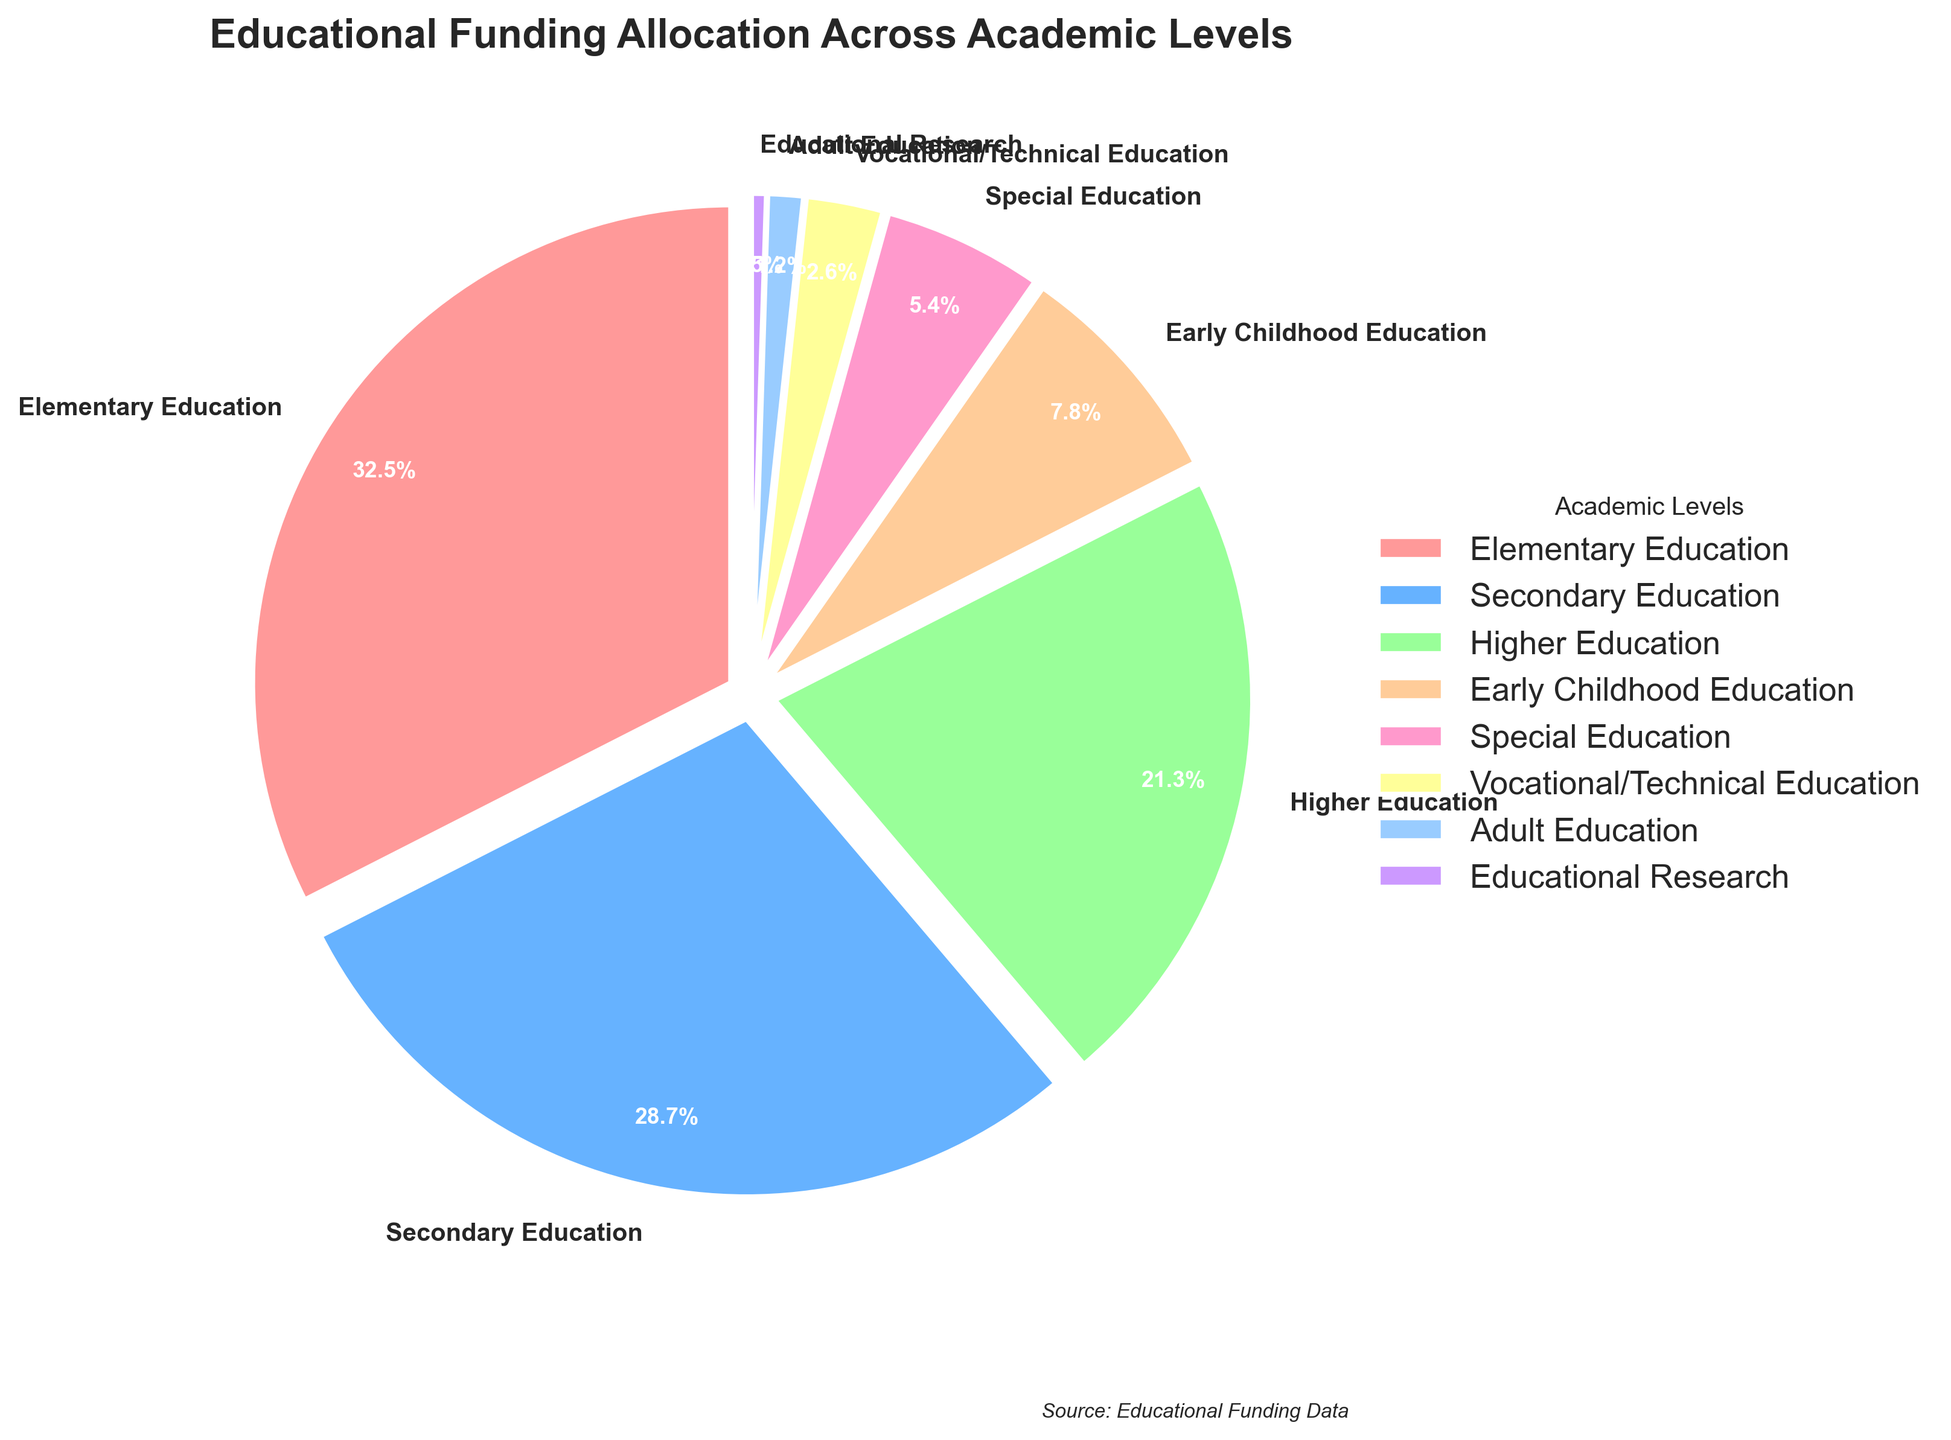Which academic level receives the largest percentage of funding? The pie chart shows the breakdown of funding allocation, and the slice representing Elementary Education is the largest. Therefore, Elementary Education has the largest percentage.
Answer: Elementary Education What is the total percentage of funding allocated to Secondary and Higher Education combined? From the chart, Secondary Education has 28.7% and Higher Education has 21.3%. Adding these two values gives 28.7 + 21.3 = 50.0%.
Answer: 50.0% How does the funding for Early Childhood Education compare to that for Special Education? The chart shows Early Childhood Education at 7.8% and Special Education at 5.4%. Early Childhood Education receives a higher percentage of funding compared to Special Education.
Answer: Early Childhood Education receives more funding Which allocation is smaller: Vocational/Technical Education or Adult Education? The pie chart shows Vocational/Technical Education at 2.6% and Adult Education at 1.2%. Comparing these, Adult Education has a smaller allocation.
Answer: Adult Education Estimate the combined funding percentage for the three smallest categories. The smallest categories in terms of funding are Educational Research (0.5%), Adult Education (1.2%), and Vocational/Technical Education (2.6%). Summing these gives 0.5 + 1.2 + 2.6 = 4.3%.
Answer: 4.3% What is the color of the segment representing Higher Education? The segment for Higher Education is the fourth largest. Visually identifying this segment in the chart shows it colored in green.
Answer: Green Which academic level has a funding allocation closest to 30%? The pie chart shows that Secondary Education is allocated 28.7%, which is closest to 30%.
Answer: Secondary Education How much more funding does Elementary Education receive compared to Special Education? From the chart, Elementary Education has 32.5% and Special Education has 5.4%. The difference is 32.5 - 5.4 = 27.1%.
Answer: 27.1% What is the difference in funding between Early Childhood Education and Vocational/Technical Education? The chart shows Early Childhood Education at 7.8% and Vocational/Technical Education at 2.6%. The difference is 7.8 - 2.6 = 5.2%.
Answer: 5.2% Name the academic level that receives less than 1% of the funding. The pie chart indicates that Educational Research receives 0.5% of the funding, which is less than 1%.
Answer: Educational Research 